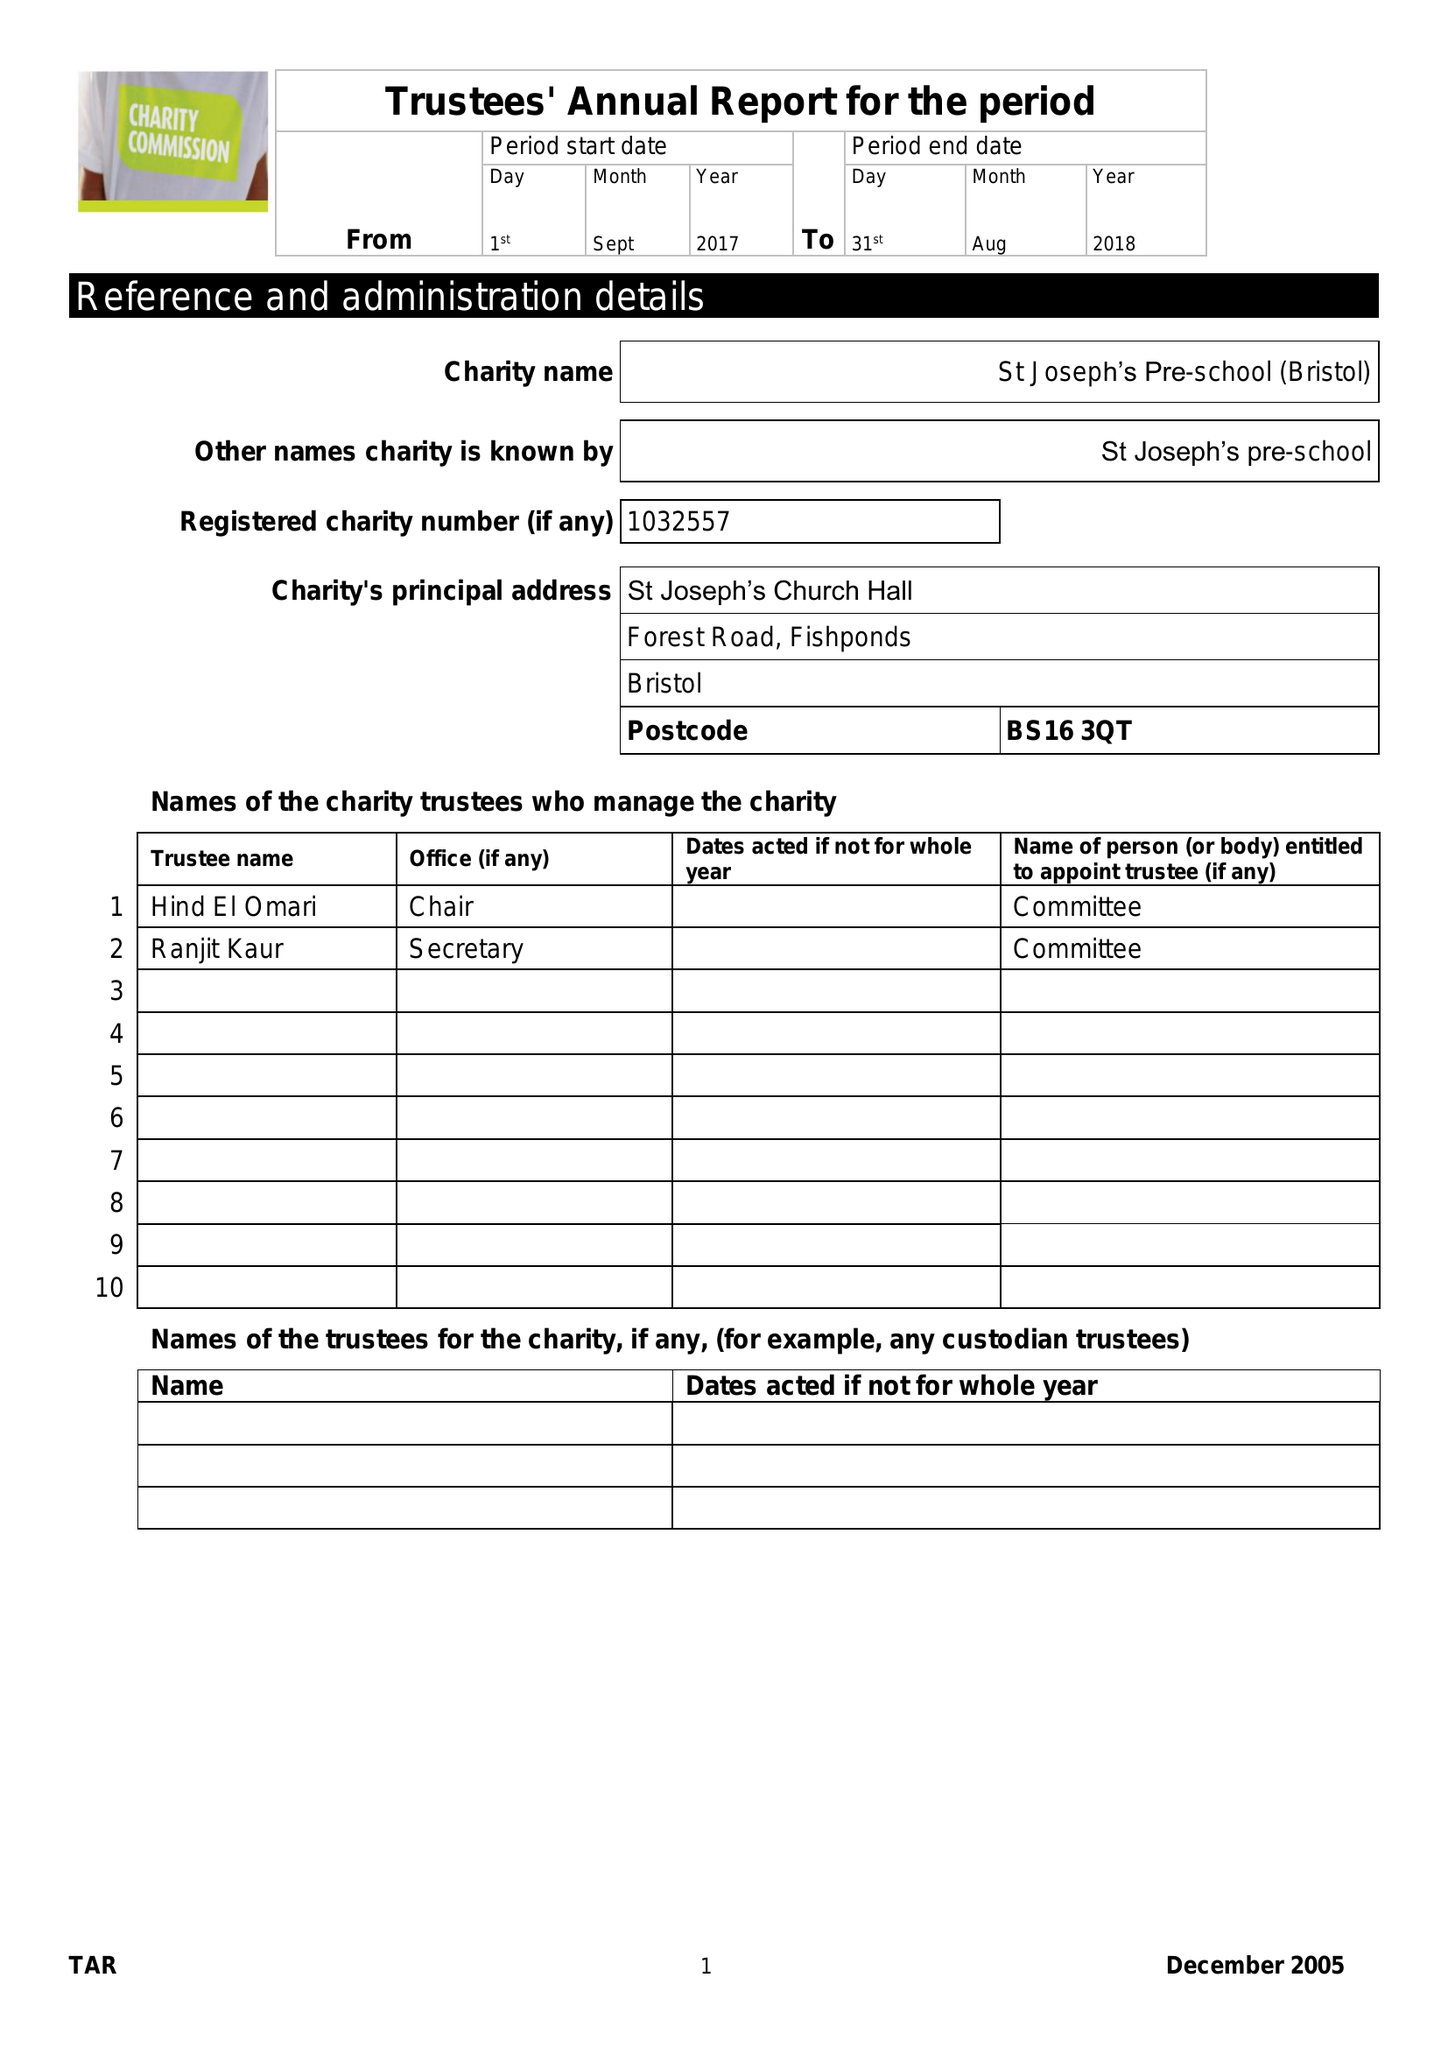What is the value for the income_annually_in_british_pounds?
Answer the question using a single word or phrase. 239442.00 